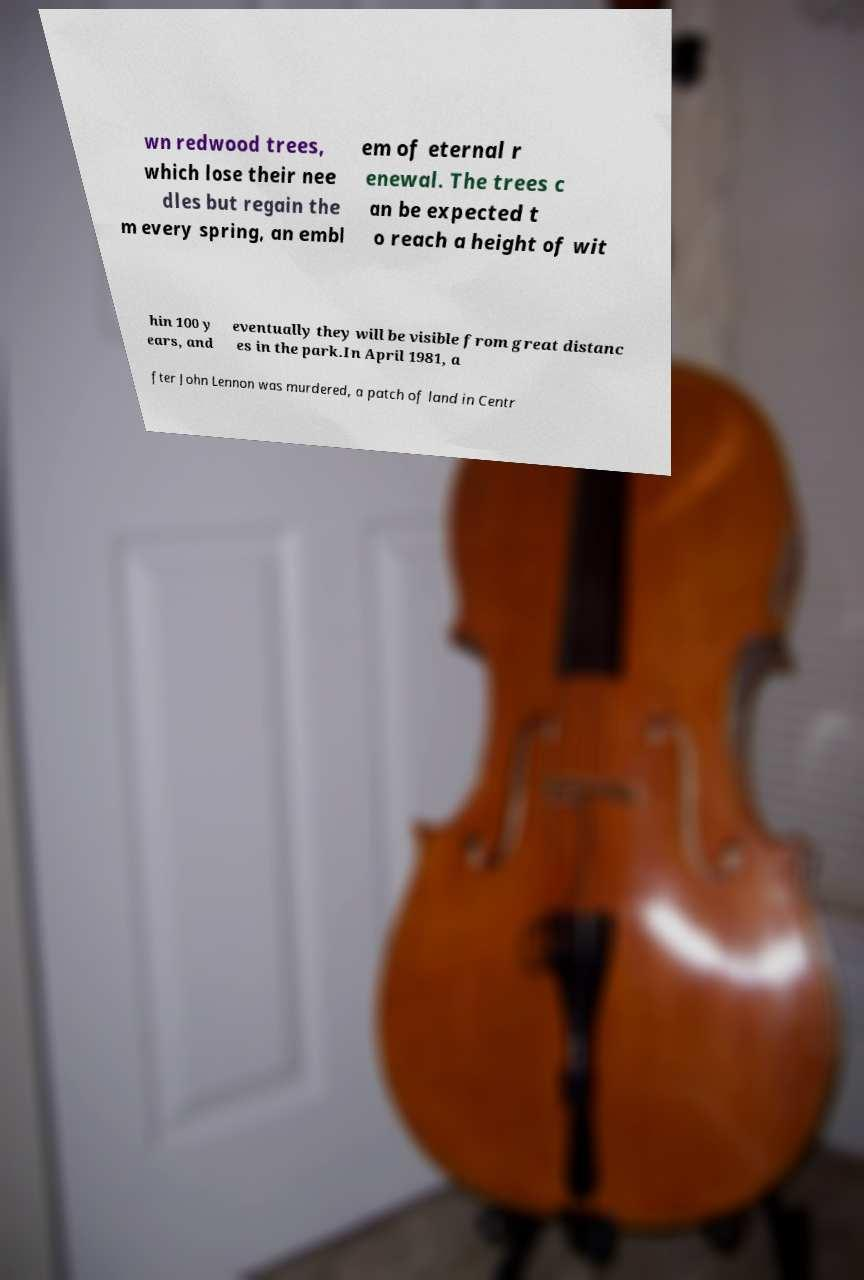There's text embedded in this image that I need extracted. Can you transcribe it verbatim? wn redwood trees, which lose their nee dles but regain the m every spring, an embl em of eternal r enewal. The trees c an be expected t o reach a height of wit hin 100 y ears, and eventually they will be visible from great distanc es in the park.In April 1981, a fter John Lennon was murdered, a patch of land in Centr 